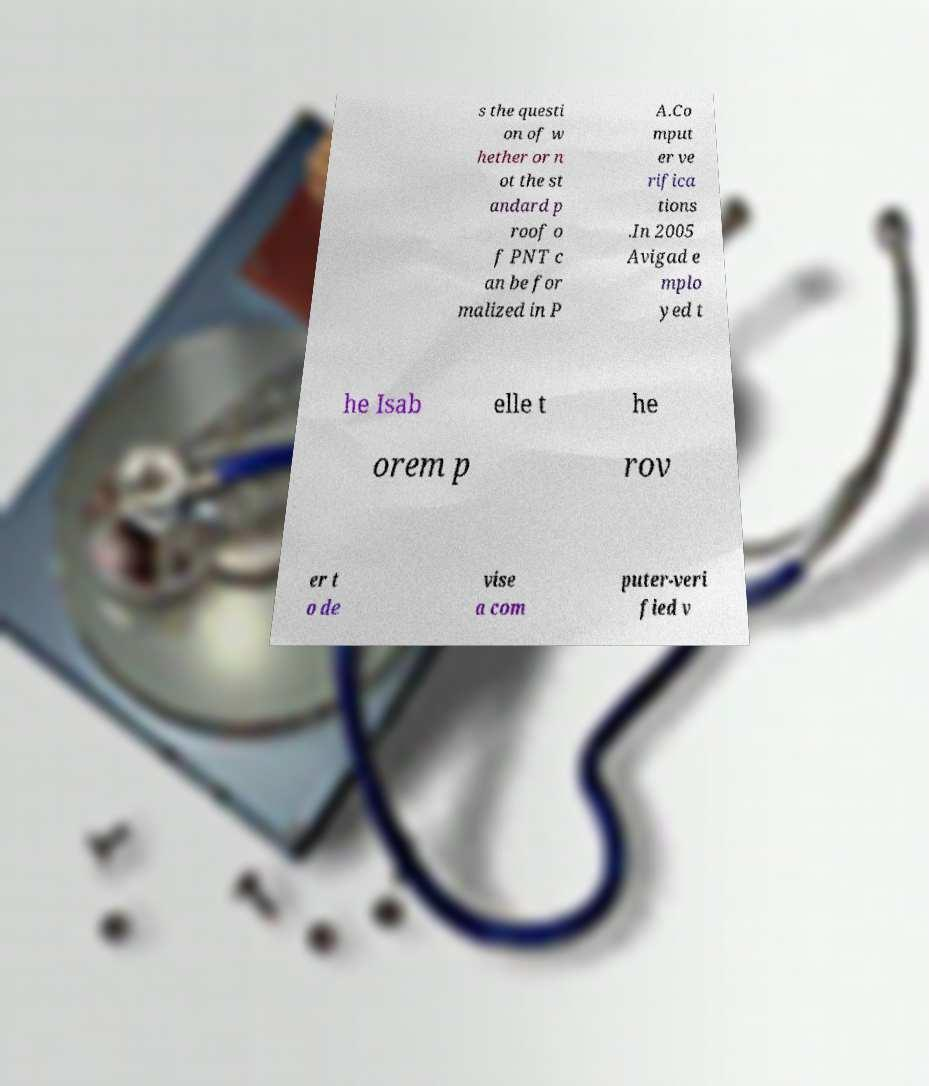Could you extract and type out the text from this image? s the questi on of w hether or n ot the st andard p roof o f PNT c an be for malized in P A.Co mput er ve rifica tions .In 2005 Avigad e mplo yed t he Isab elle t he orem p rov er t o de vise a com puter-veri fied v 